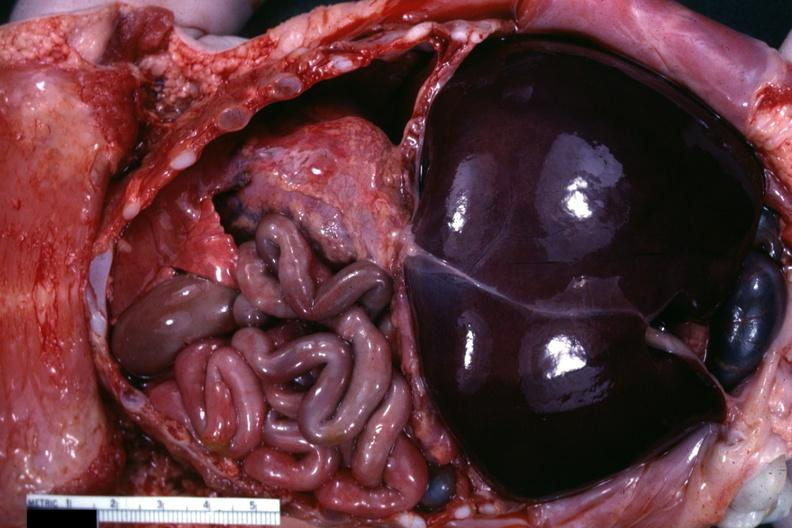what is present?
Answer the question using a single word or phrase. Soft tissue 